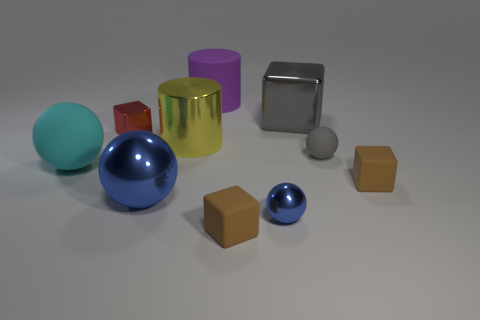Is the color of the small rubber sphere the same as the shiny cube that is right of the tiny metallic cube?
Your answer should be compact. Yes. How many other things are there of the same material as the small red thing?
Ensure brevity in your answer.  4. The purple thing that is the same material as the large cyan thing is what shape?
Offer a very short reply. Cylinder. Is there any other thing that has the same color as the big matte sphere?
Your answer should be compact. No. What size is the other sphere that is the same color as the tiny shiny sphere?
Offer a very short reply. Large. Are there more blue spheres left of the purple matte cylinder than large yellow matte cubes?
Provide a short and direct response. Yes. There is a large yellow object; is it the same shape as the tiny red thing behind the cyan thing?
Ensure brevity in your answer.  No. How many other shiny cylinders are the same size as the metallic cylinder?
Provide a short and direct response. 0. What number of objects are to the right of the metal cube to the right of the small metallic thing that is to the right of the large yellow object?
Your answer should be compact. 2. Is the number of large cyan rubber things that are on the left side of the big cyan sphere the same as the number of gray metal blocks to the left of the big yellow cylinder?
Give a very brief answer. Yes. 